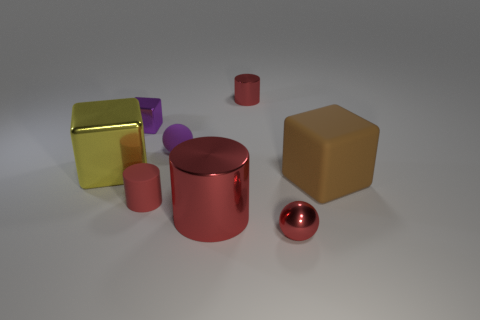Add 1 big cyan rubber cylinders. How many objects exist? 9 Subtract all cubes. How many objects are left? 5 Subtract 0 gray cylinders. How many objects are left? 8 Subtract all tiny things. Subtract all cubes. How many objects are left? 0 Add 7 big cylinders. How many big cylinders are left? 8 Add 6 yellow cubes. How many yellow cubes exist? 7 